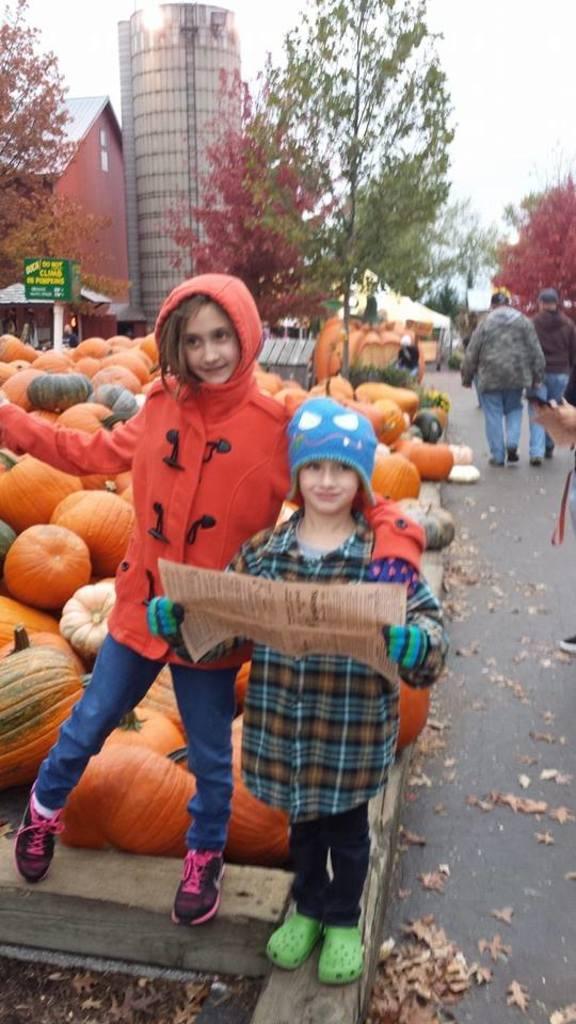Please provide a concise description of this image. This image consists of two girls standing in the front. The girl wearing blue cap is holding a newspaper. Behind them, there are pumpkins. At the bottom, there is a road. In the background, there are trees along with a house and a tank. 